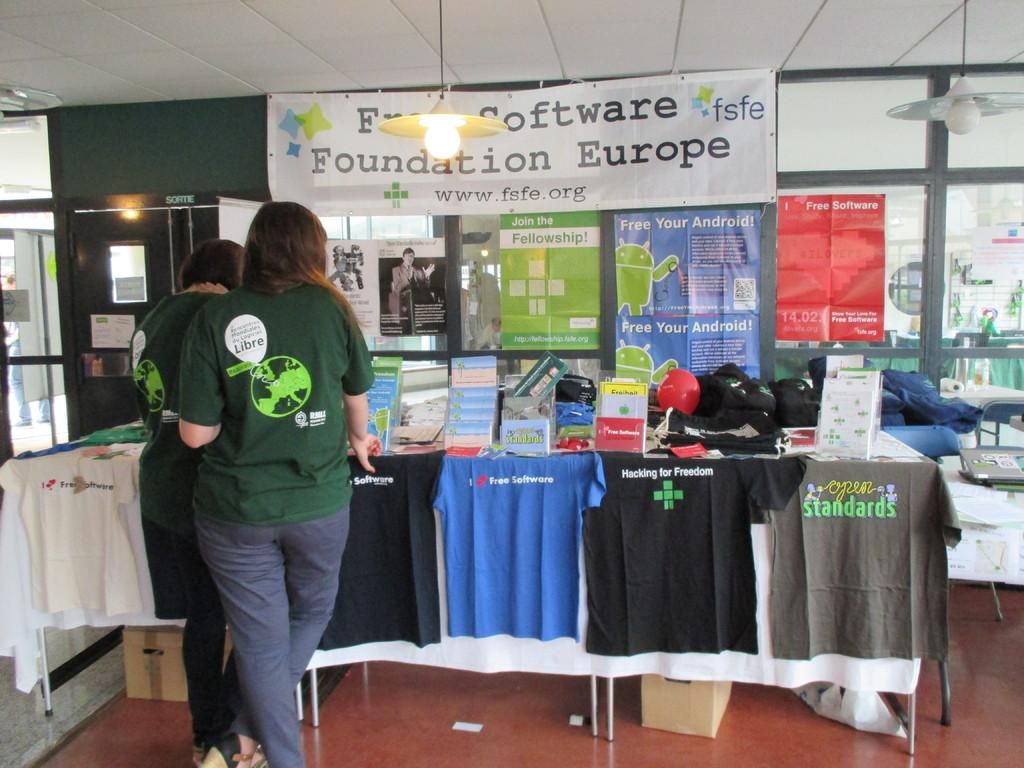<image>
Provide a brief description of the given image. a white item that says Foundation Europe on it 